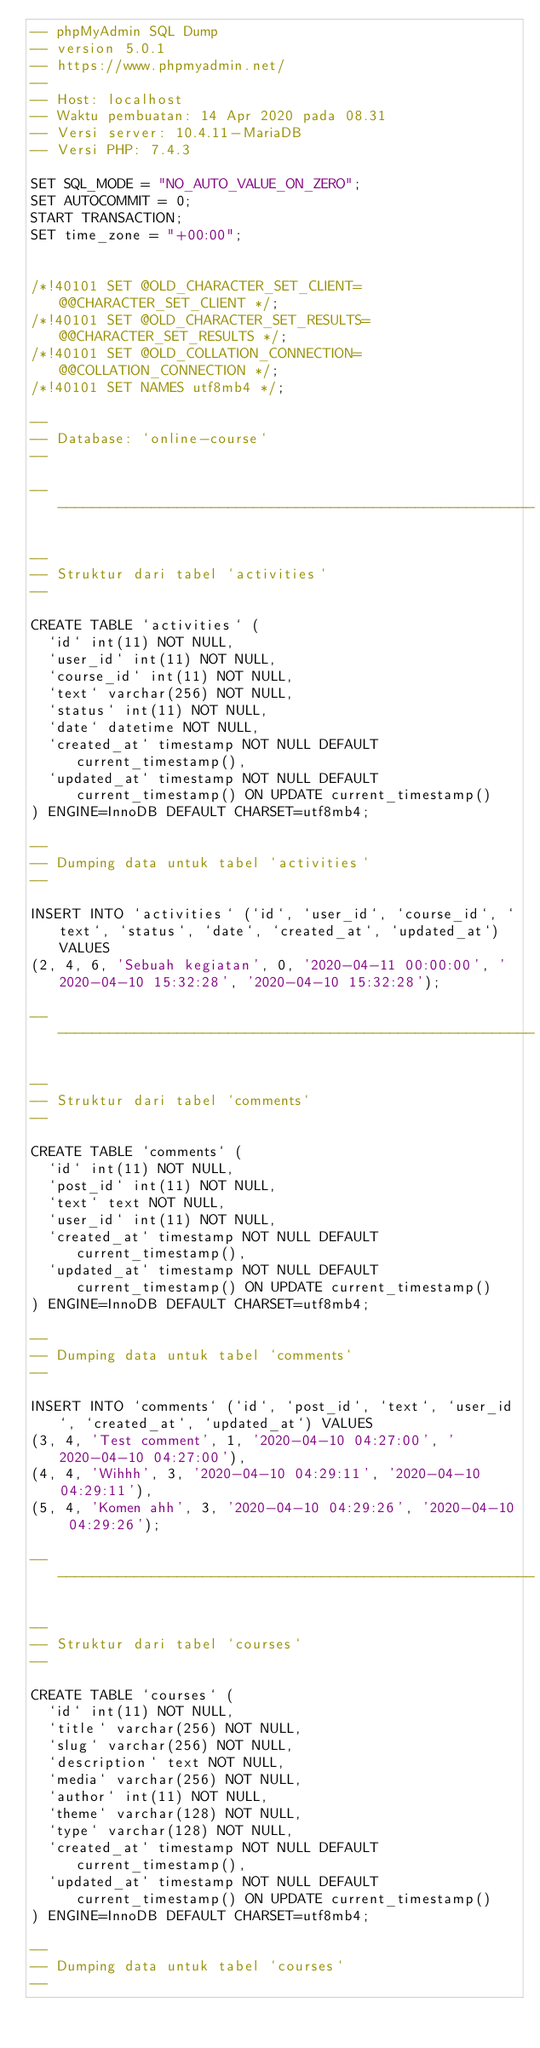<code> <loc_0><loc_0><loc_500><loc_500><_SQL_>-- phpMyAdmin SQL Dump
-- version 5.0.1
-- https://www.phpmyadmin.net/
--
-- Host: localhost
-- Waktu pembuatan: 14 Apr 2020 pada 08.31
-- Versi server: 10.4.11-MariaDB
-- Versi PHP: 7.4.3

SET SQL_MODE = "NO_AUTO_VALUE_ON_ZERO";
SET AUTOCOMMIT = 0;
START TRANSACTION;
SET time_zone = "+00:00";


/*!40101 SET @OLD_CHARACTER_SET_CLIENT=@@CHARACTER_SET_CLIENT */;
/*!40101 SET @OLD_CHARACTER_SET_RESULTS=@@CHARACTER_SET_RESULTS */;
/*!40101 SET @OLD_COLLATION_CONNECTION=@@COLLATION_CONNECTION */;
/*!40101 SET NAMES utf8mb4 */;

--
-- Database: `online-course`
--

-- --------------------------------------------------------

--
-- Struktur dari tabel `activities`
--

CREATE TABLE `activities` (
  `id` int(11) NOT NULL,
  `user_id` int(11) NOT NULL,
  `course_id` int(11) NOT NULL,
  `text` varchar(256) NOT NULL,
  `status` int(11) NOT NULL,
  `date` datetime NOT NULL,
  `created_at` timestamp NOT NULL DEFAULT current_timestamp(),
  `updated_at` timestamp NOT NULL DEFAULT current_timestamp() ON UPDATE current_timestamp()
) ENGINE=InnoDB DEFAULT CHARSET=utf8mb4;

--
-- Dumping data untuk tabel `activities`
--

INSERT INTO `activities` (`id`, `user_id`, `course_id`, `text`, `status`, `date`, `created_at`, `updated_at`) VALUES
(2, 4, 6, 'Sebuah kegiatan', 0, '2020-04-11 00:00:00', '2020-04-10 15:32:28', '2020-04-10 15:32:28');

-- --------------------------------------------------------

--
-- Struktur dari tabel `comments`
--

CREATE TABLE `comments` (
  `id` int(11) NOT NULL,
  `post_id` int(11) NOT NULL,
  `text` text NOT NULL,
  `user_id` int(11) NOT NULL,
  `created_at` timestamp NOT NULL DEFAULT current_timestamp(),
  `updated_at` timestamp NOT NULL DEFAULT current_timestamp() ON UPDATE current_timestamp()
) ENGINE=InnoDB DEFAULT CHARSET=utf8mb4;

--
-- Dumping data untuk tabel `comments`
--

INSERT INTO `comments` (`id`, `post_id`, `text`, `user_id`, `created_at`, `updated_at`) VALUES
(3, 4, 'Test comment', 1, '2020-04-10 04:27:00', '2020-04-10 04:27:00'),
(4, 4, 'Wihhh', 3, '2020-04-10 04:29:11', '2020-04-10 04:29:11'),
(5, 4, 'Komen ahh', 3, '2020-04-10 04:29:26', '2020-04-10 04:29:26');

-- --------------------------------------------------------

--
-- Struktur dari tabel `courses`
--

CREATE TABLE `courses` (
  `id` int(11) NOT NULL,
  `title` varchar(256) NOT NULL,
  `slug` varchar(256) NOT NULL,
  `description` text NOT NULL,
  `media` varchar(256) NOT NULL,
  `author` int(11) NOT NULL,
  `theme` varchar(128) NOT NULL,
  `type` varchar(128) NOT NULL,
  `created_at` timestamp NOT NULL DEFAULT current_timestamp(),
  `updated_at` timestamp NOT NULL DEFAULT current_timestamp() ON UPDATE current_timestamp()
) ENGINE=InnoDB DEFAULT CHARSET=utf8mb4;

--
-- Dumping data untuk tabel `courses`
--
</code> 